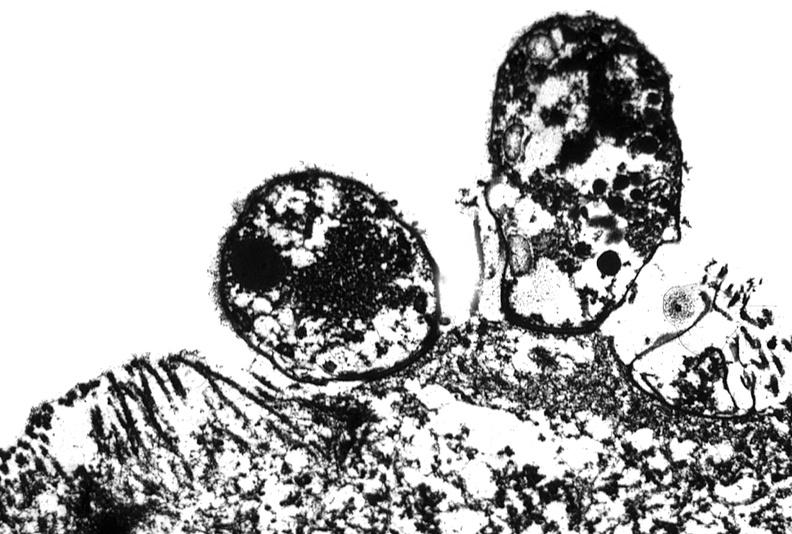what does this image show?
Answer the question using a single word or phrase. Colon biopsy 